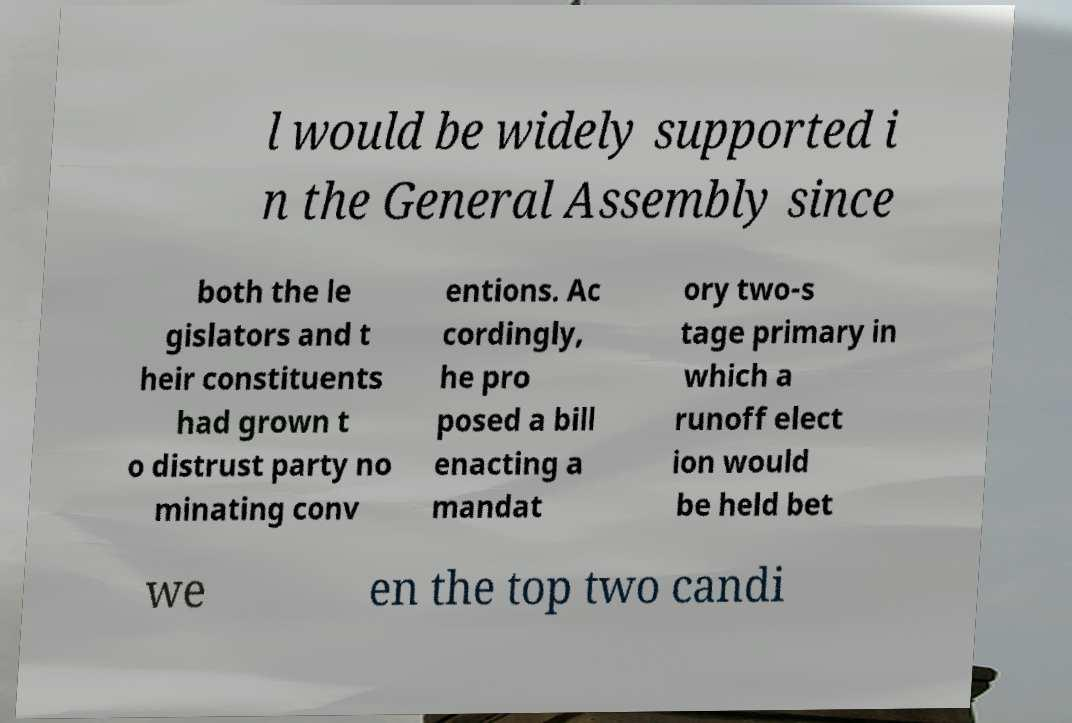Could you assist in decoding the text presented in this image and type it out clearly? l would be widely supported i n the General Assembly since both the le gislators and t heir constituents had grown t o distrust party no minating conv entions. Ac cordingly, he pro posed a bill enacting a mandat ory two-s tage primary in which a runoff elect ion would be held bet we en the top two candi 